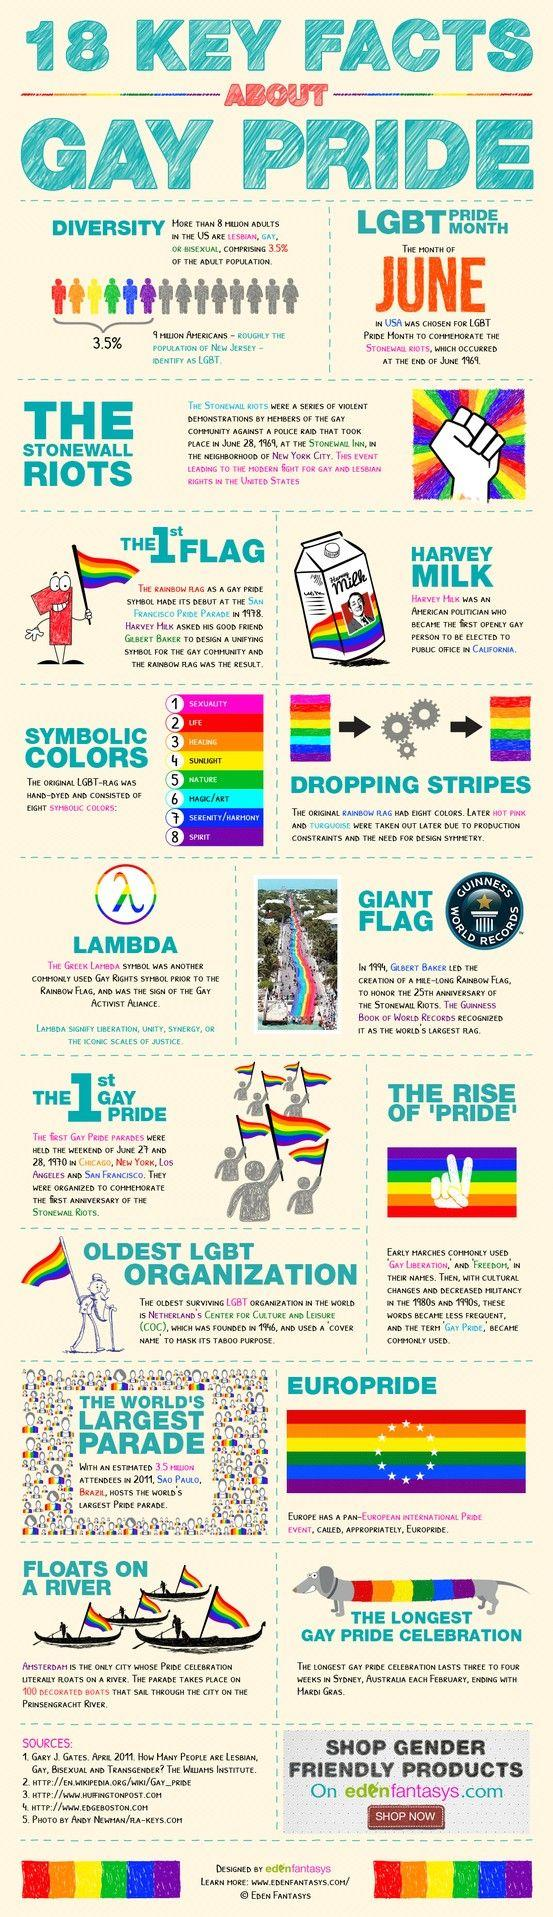Draw attention to some important aspects in this diagram. The color red in the LGBT flag signifies life, emphasizing the importance of celebrating and promoting the dignity and worth of all individuals, regardless of their sexual orientation or gender identity. 